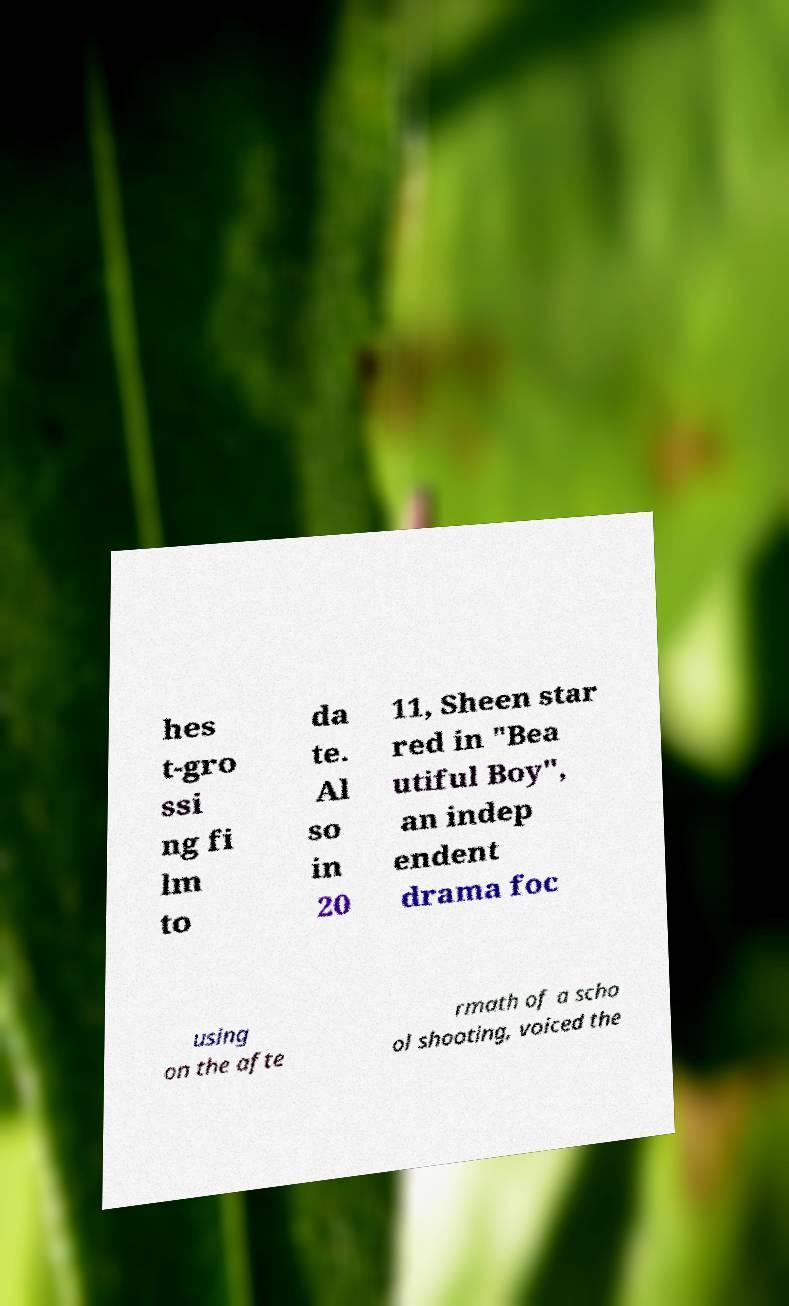Can you read and provide the text displayed in the image?This photo seems to have some interesting text. Can you extract and type it out for me? hes t-gro ssi ng fi lm to da te. Al so in 20 11, Sheen star red in "Bea utiful Boy", an indep endent drama foc using on the afte rmath of a scho ol shooting, voiced the 